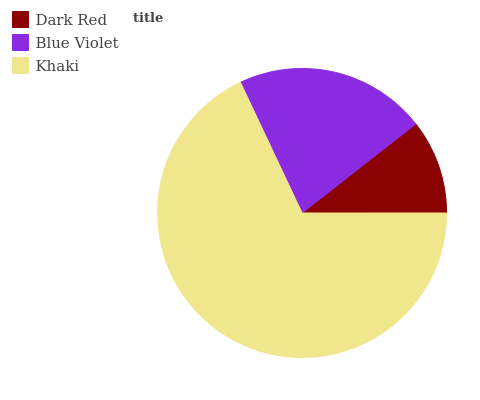Is Dark Red the minimum?
Answer yes or no. Yes. Is Khaki the maximum?
Answer yes or no. Yes. Is Blue Violet the minimum?
Answer yes or no. No. Is Blue Violet the maximum?
Answer yes or no. No. Is Blue Violet greater than Dark Red?
Answer yes or no. Yes. Is Dark Red less than Blue Violet?
Answer yes or no. Yes. Is Dark Red greater than Blue Violet?
Answer yes or no. No. Is Blue Violet less than Dark Red?
Answer yes or no. No. Is Blue Violet the high median?
Answer yes or no. Yes. Is Blue Violet the low median?
Answer yes or no. Yes. Is Dark Red the high median?
Answer yes or no. No. Is Khaki the low median?
Answer yes or no. No. 